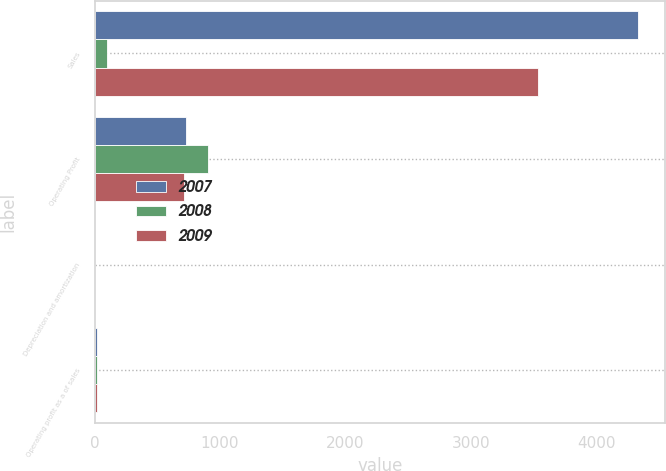Convert chart. <chart><loc_0><loc_0><loc_500><loc_500><stacked_bar_chart><ecel><fcel>Sales<fcel>Operating Profit<fcel>Depreciation and amortization<fcel>Operating profit as a of sales<nl><fcel>2007<fcel>4330.7<fcel>728.5<fcel>3.1<fcel>16.8<nl><fcel>2008<fcel>97.6<fcel>907.3<fcel>2.7<fcel>18.7<nl><fcel>2009<fcel>3537.9<fcel>709.5<fcel>1.8<fcel>20.1<nl></chart> 